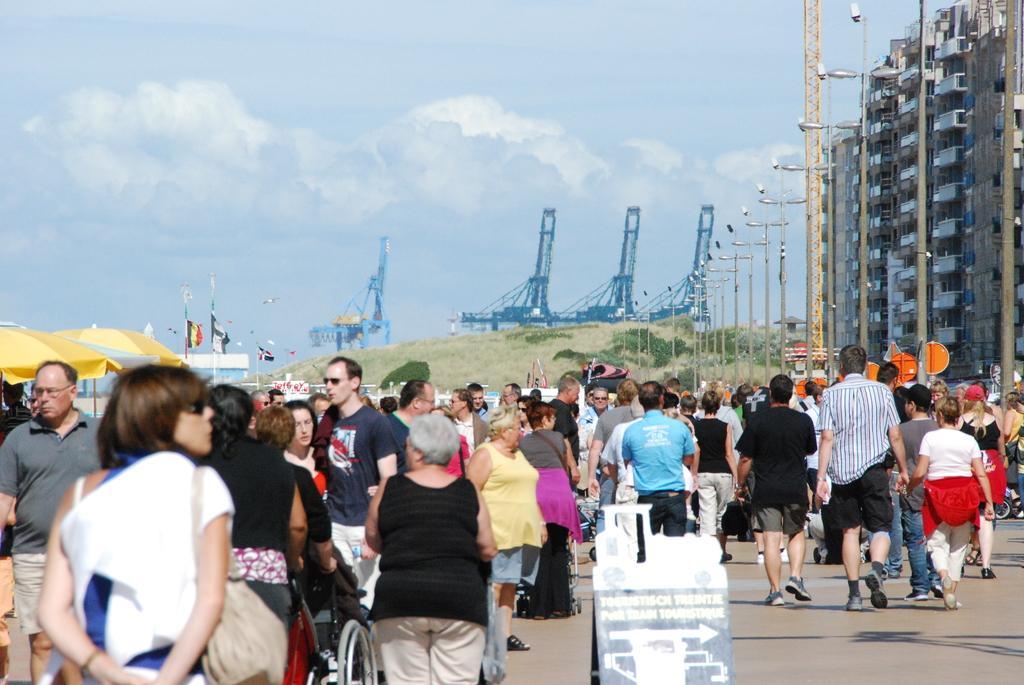Could you give a brief overview of what you see in this image? People are walking. There is a board at the front. A person is sitting on a wheelchair at the left. There are tents and flags at the left. There are poles and buildings at the right. There is grass at the back and there are clouds in the sky. 